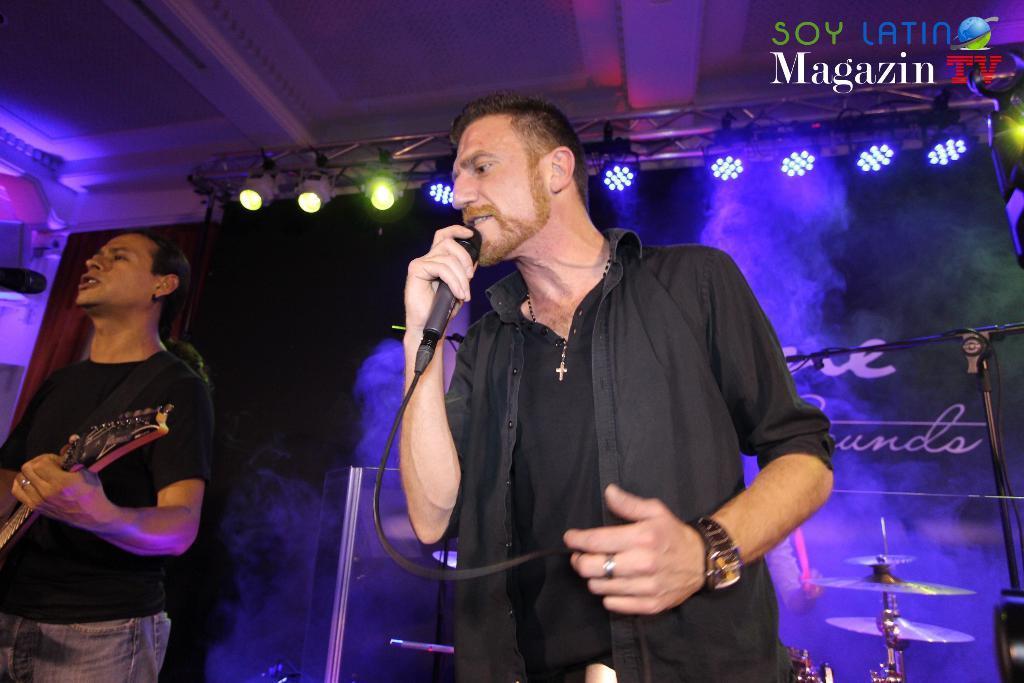Could you give a brief overview of what you see in this image? In this picture we can see two men standing here, a man on the left side is playing a guitar, a man on the right side is holding a microphone, we can see some lights here, in the background we can see cymbals, at the right top of the image we can see a logo and some text. 